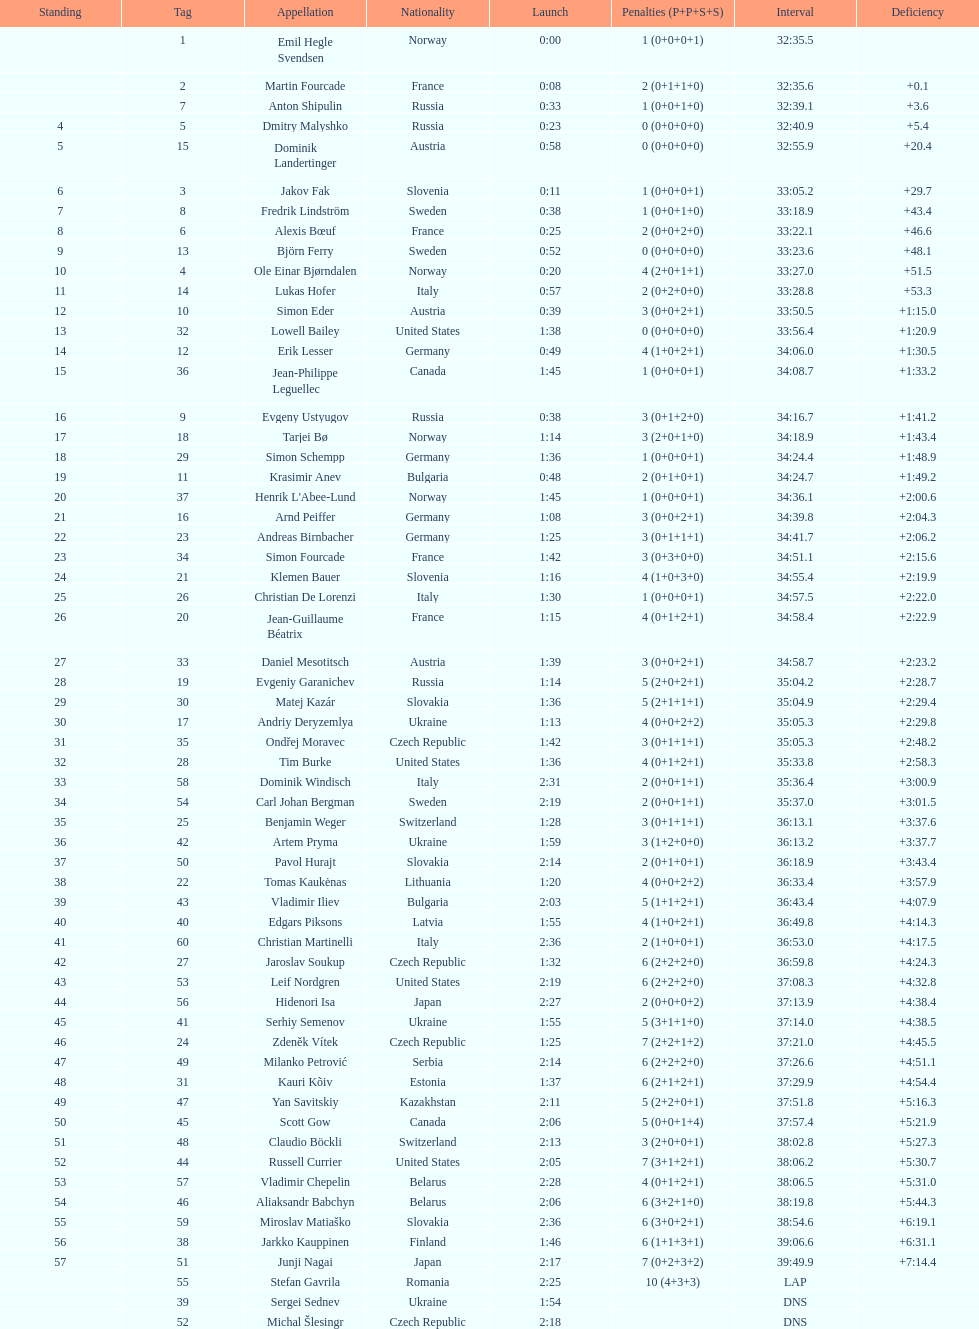Between bjorn ferry, simon elder and erik lesser - who had the most penalties? Erik Lesser. 